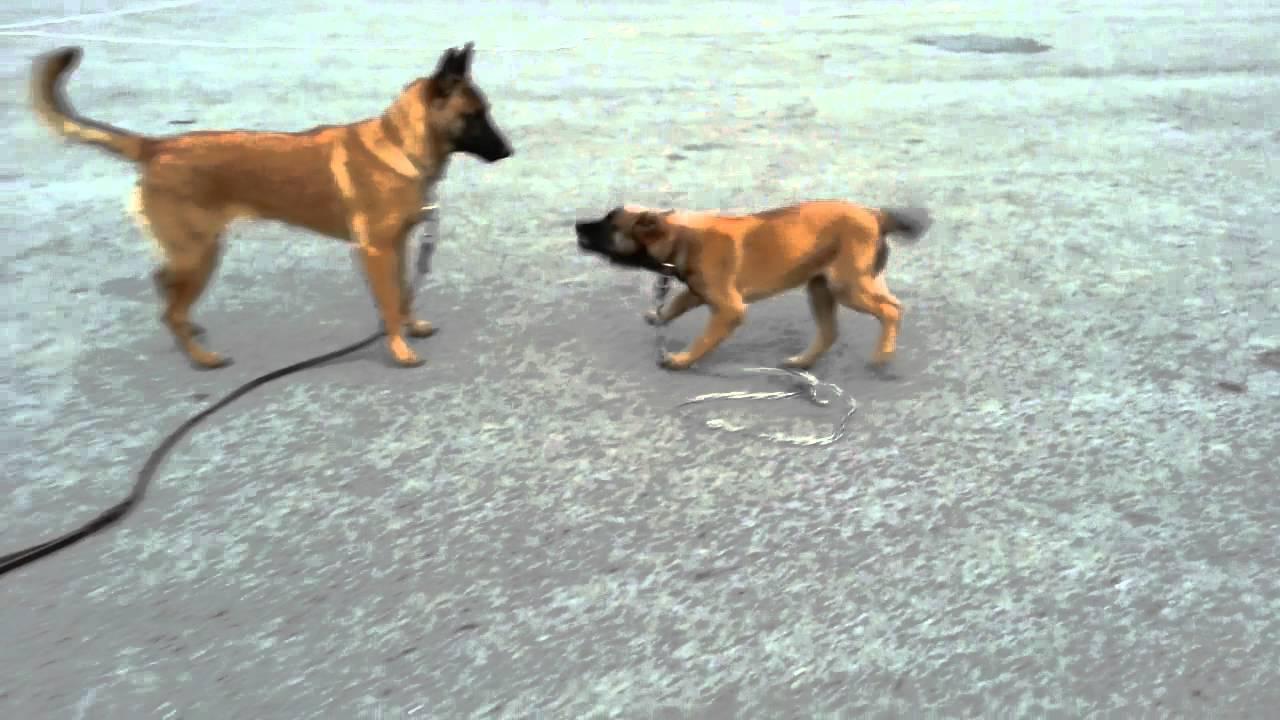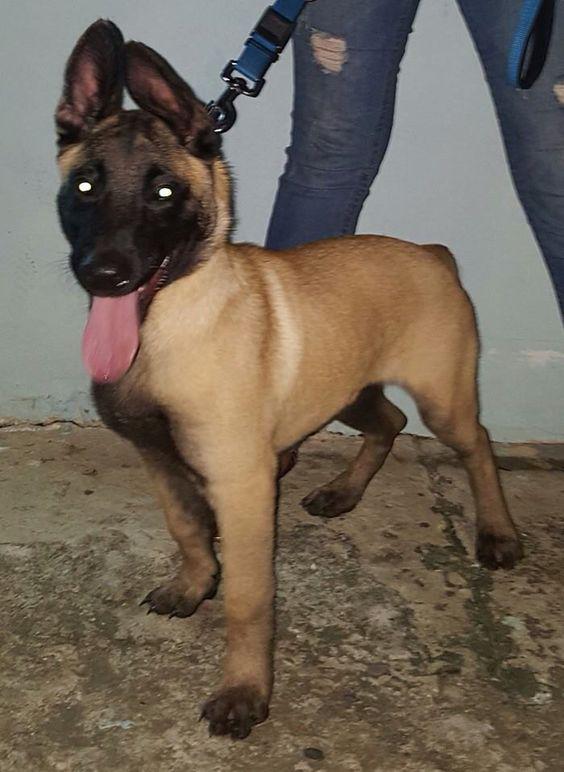The first image is the image on the left, the second image is the image on the right. Evaluate the accuracy of this statement regarding the images: "In one of the images there is a large dog laying in the grass.". Is it true? Answer yes or no. No. The first image is the image on the left, the second image is the image on the right. For the images shown, is this caption "An image shows exactly one german shepherd dog, which is reclining on the grass." true? Answer yes or no. No. 